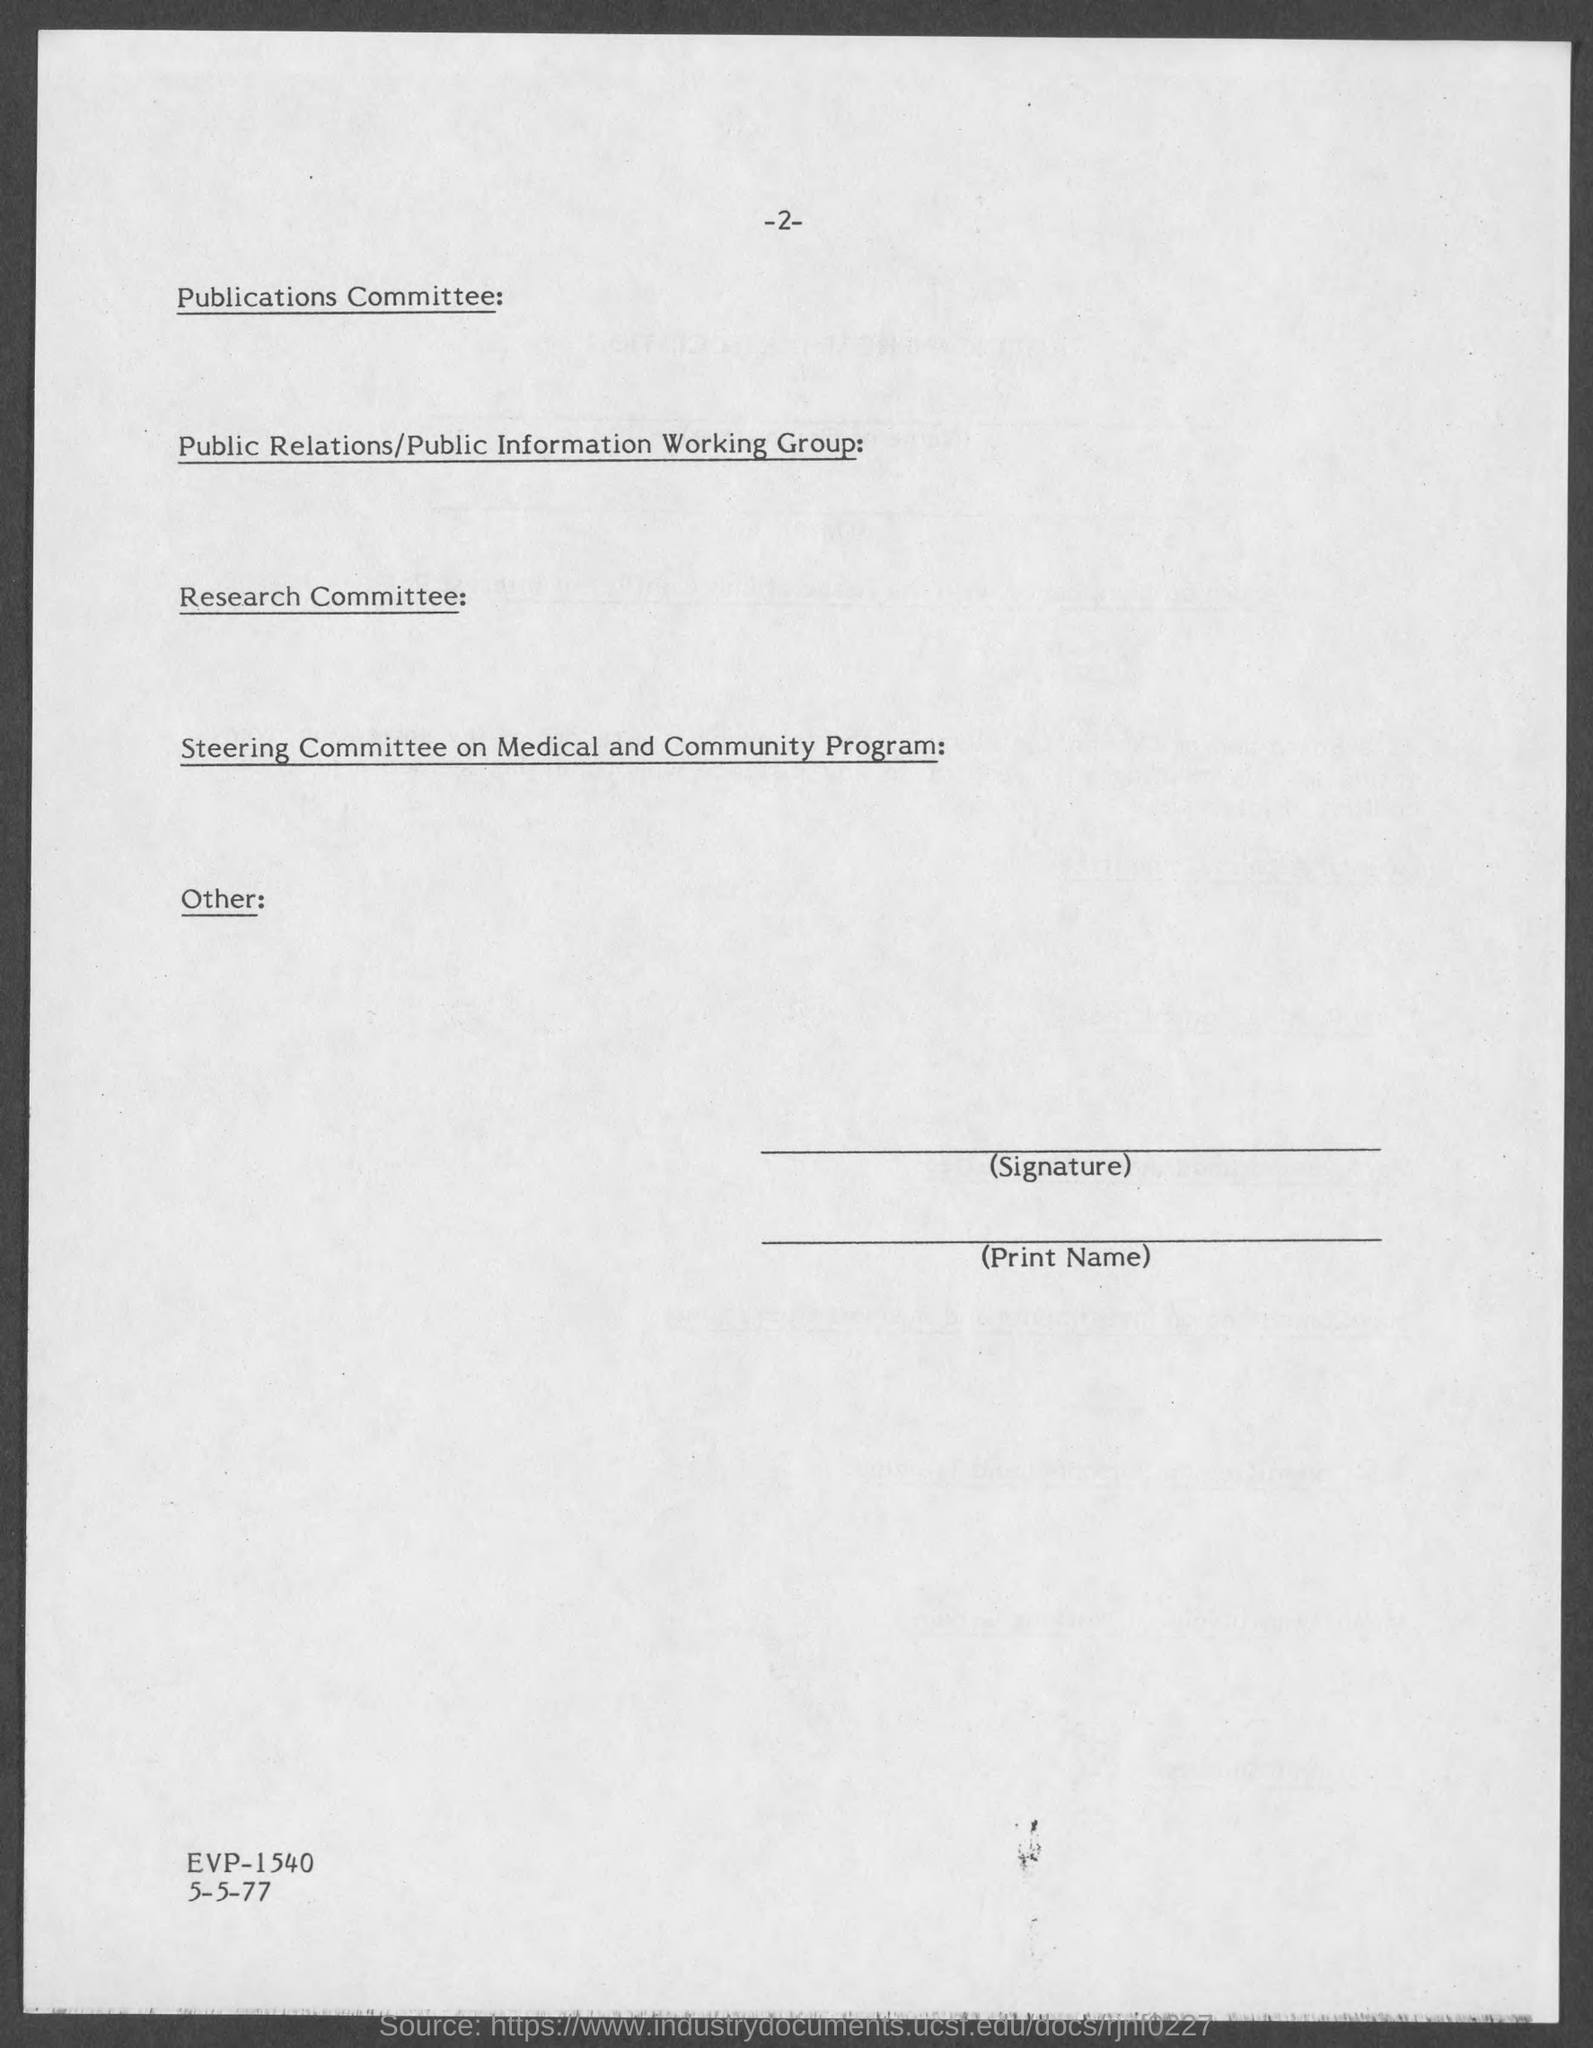What is the page number at top of the page?
Give a very brief answer. 2. 